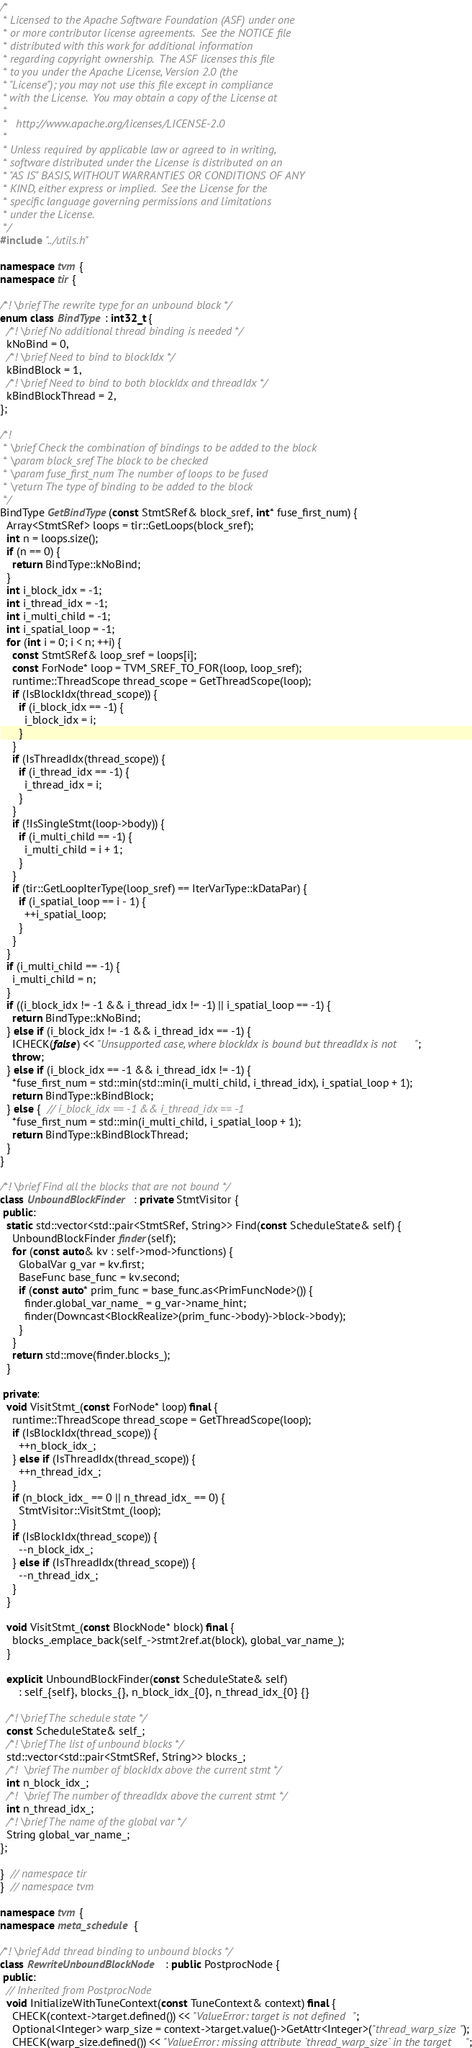<code> <loc_0><loc_0><loc_500><loc_500><_C++_>/*
 * Licensed to the Apache Software Foundation (ASF) under one
 * or more contributor license agreements.  See the NOTICE file
 * distributed with this work for additional information
 * regarding copyright ownership.  The ASF licenses this file
 * to you under the Apache License, Version 2.0 (the
 * "License"); you may not use this file except in compliance
 * with the License.  You may obtain a copy of the License at
 *
 *   http://www.apache.org/licenses/LICENSE-2.0
 *
 * Unless required by applicable law or agreed to in writing,
 * software distributed under the License is distributed on an
 * "AS IS" BASIS, WITHOUT WARRANTIES OR CONDITIONS OF ANY
 * KIND, either express or implied.  See the License for the
 * specific language governing permissions and limitations
 * under the License.
 */
#include "../utils.h"

namespace tvm {
namespace tir {

/*! \brief The rewrite type for an unbound block */
enum class BindType : int32_t {
  /*! \brief No additional thread binding is needed */
  kNoBind = 0,
  /*! \brief Need to bind to blockIdx */
  kBindBlock = 1,
  /*! \brief Need to bind to both blockIdx and threadIdx */
  kBindBlockThread = 2,
};

/*!
 * \brief Check the combination of bindings to be added to the block
 * \param block_sref The block to be checked
 * \param fuse_first_num The number of loops to be fused
 * \return The type of binding to be added to the block
 */
BindType GetBindType(const StmtSRef& block_sref, int* fuse_first_num) {
  Array<StmtSRef> loops = tir::GetLoops(block_sref);
  int n = loops.size();
  if (n == 0) {
    return BindType::kNoBind;
  }
  int i_block_idx = -1;
  int i_thread_idx = -1;
  int i_multi_child = -1;
  int i_spatial_loop = -1;
  for (int i = 0; i < n; ++i) {
    const StmtSRef& loop_sref = loops[i];
    const ForNode* loop = TVM_SREF_TO_FOR(loop, loop_sref);
    runtime::ThreadScope thread_scope = GetThreadScope(loop);
    if (IsBlockIdx(thread_scope)) {
      if (i_block_idx == -1) {
        i_block_idx = i;
      }
    }
    if (IsThreadIdx(thread_scope)) {
      if (i_thread_idx == -1) {
        i_thread_idx = i;
      }
    }
    if (!IsSingleStmt(loop->body)) {
      if (i_multi_child == -1) {
        i_multi_child = i + 1;
      }
    }
    if (tir::GetLoopIterType(loop_sref) == IterVarType::kDataPar) {
      if (i_spatial_loop == i - 1) {
        ++i_spatial_loop;
      }
    }
  }
  if (i_multi_child == -1) {
    i_multi_child = n;
  }
  if ((i_block_idx != -1 && i_thread_idx != -1) || i_spatial_loop == -1) {
    return BindType::kNoBind;
  } else if (i_block_idx != -1 && i_thread_idx == -1) {
    ICHECK(false) << "Unsupported case, where blockIdx is bound but threadIdx is not";
    throw;
  } else if (i_block_idx == -1 && i_thread_idx != -1) {
    *fuse_first_num = std::min(std::min(i_multi_child, i_thread_idx), i_spatial_loop + 1);
    return BindType::kBindBlock;
  } else {  // i_block_idx == -1 && i_thread_idx == -1
    *fuse_first_num = std::min(i_multi_child, i_spatial_loop + 1);
    return BindType::kBindBlockThread;
  }
}

/*! \brief Find all the blocks that are not bound */
class UnboundBlockFinder : private StmtVisitor {
 public:
  static std::vector<std::pair<StmtSRef, String>> Find(const ScheduleState& self) {
    UnboundBlockFinder finder(self);
    for (const auto& kv : self->mod->functions) {
      GlobalVar g_var = kv.first;
      BaseFunc base_func = kv.second;
      if (const auto* prim_func = base_func.as<PrimFuncNode>()) {
        finder.global_var_name_ = g_var->name_hint;
        finder(Downcast<BlockRealize>(prim_func->body)->block->body);
      }
    }
    return std::move(finder.blocks_);
  }

 private:
  void VisitStmt_(const ForNode* loop) final {
    runtime::ThreadScope thread_scope = GetThreadScope(loop);
    if (IsBlockIdx(thread_scope)) {
      ++n_block_idx_;
    } else if (IsThreadIdx(thread_scope)) {
      ++n_thread_idx_;
    }
    if (n_block_idx_ == 0 || n_thread_idx_ == 0) {
      StmtVisitor::VisitStmt_(loop);
    }
    if (IsBlockIdx(thread_scope)) {
      --n_block_idx_;
    } else if (IsThreadIdx(thread_scope)) {
      --n_thread_idx_;
    }
  }

  void VisitStmt_(const BlockNode* block) final {
    blocks_.emplace_back(self_->stmt2ref.at(block), global_var_name_);
  }

  explicit UnboundBlockFinder(const ScheduleState& self)
      : self_{self}, blocks_{}, n_block_idx_{0}, n_thread_idx_{0} {}

  /*! \brief The schedule state */
  const ScheduleState& self_;
  /*! \brief The list of unbound blocks */
  std::vector<std::pair<StmtSRef, String>> blocks_;
  /*!  \brief The number of blockIdx above the current stmt */
  int n_block_idx_;
  /*!  \brief The number of threadIdx above the current stmt */
  int n_thread_idx_;
  /*! \brief The name of the global var */
  String global_var_name_;
};

}  // namespace tir
}  // namespace tvm

namespace tvm {
namespace meta_schedule {

/*! \brief Add thread binding to unbound blocks */
class RewriteUnboundBlockNode : public PostprocNode {
 public:
  // Inherited from PostprocNode
  void InitializeWithTuneContext(const TuneContext& context) final {
    CHECK(context->target.defined()) << "ValueError: target is not defined";
    Optional<Integer> warp_size = context->target.value()->GetAttr<Integer>("thread_warp_size");
    CHECK(warp_size.defined()) << "ValueError: missing attribute `thread_warp_size` in the target";</code> 